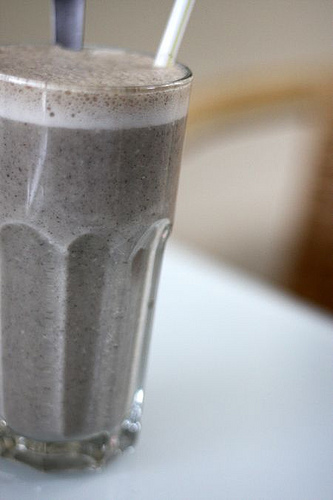<image>
Can you confirm if the glass is to the left of the drink? No. The glass is not to the left of the drink. From this viewpoint, they have a different horizontal relationship. 